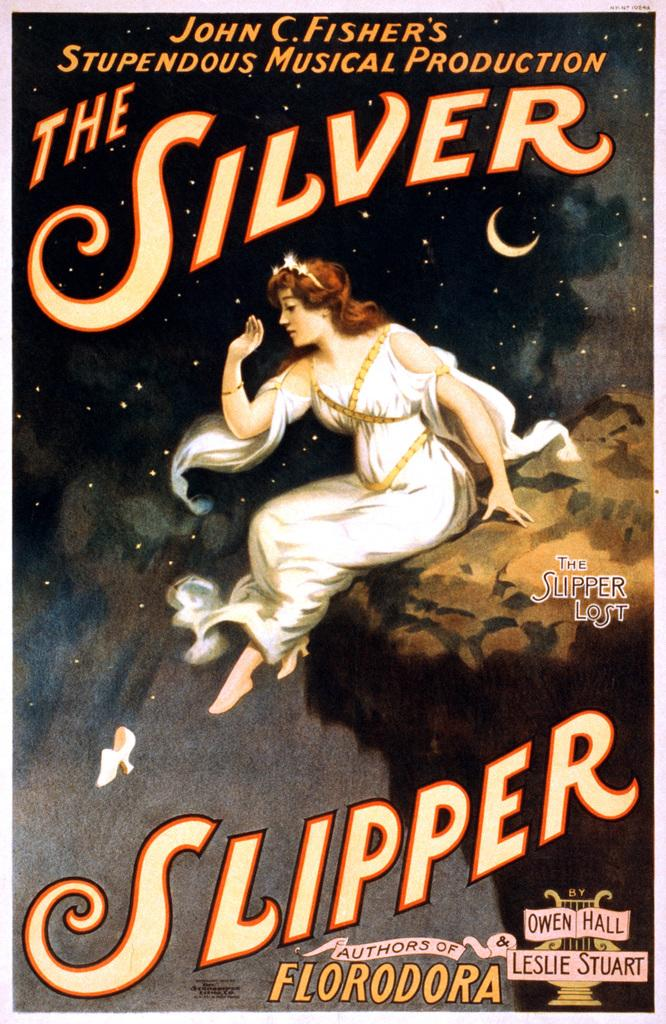<image>
Render a clear and concise summary of the photo. A poster for a musical production from John Fisher called The Silver Slipper. 